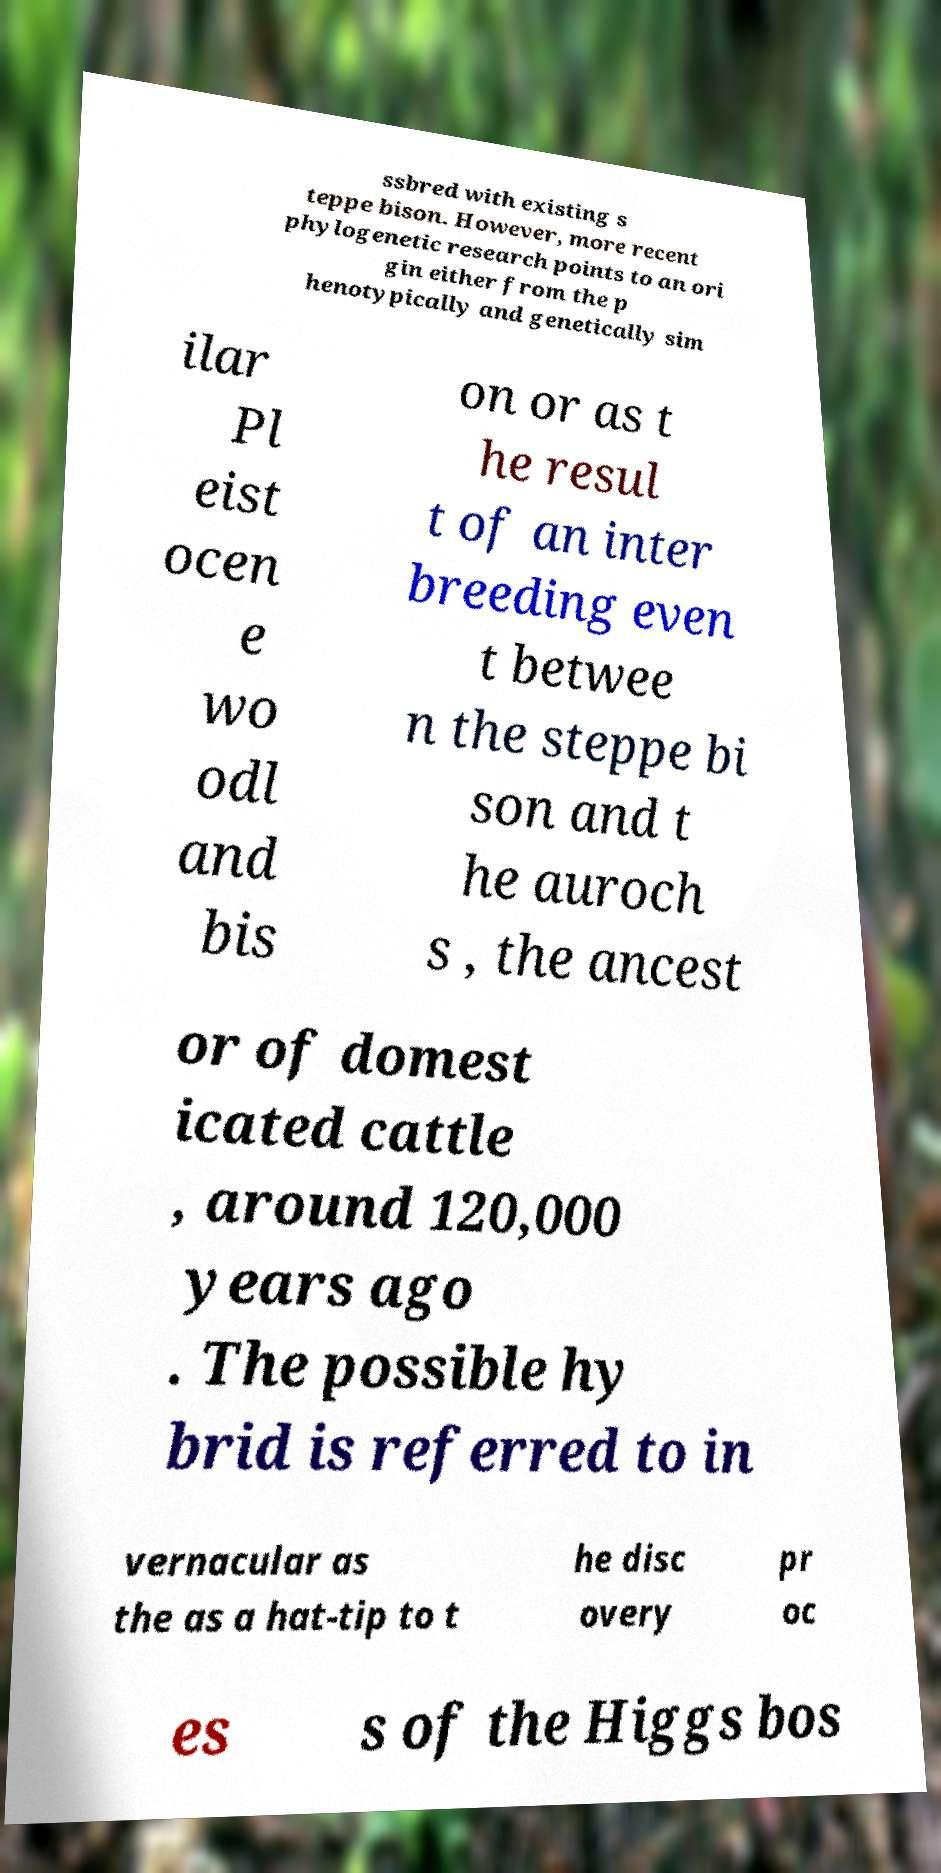What messages or text are displayed in this image? I need them in a readable, typed format. ssbred with existing s teppe bison. However, more recent phylogenetic research points to an ori gin either from the p henotypically and genetically sim ilar Pl eist ocen e wo odl and bis on or as t he resul t of an inter breeding even t betwee n the steppe bi son and t he auroch s , the ancest or of domest icated cattle , around 120,000 years ago . The possible hy brid is referred to in vernacular as the as a hat-tip to t he disc overy pr oc es s of the Higgs bos 